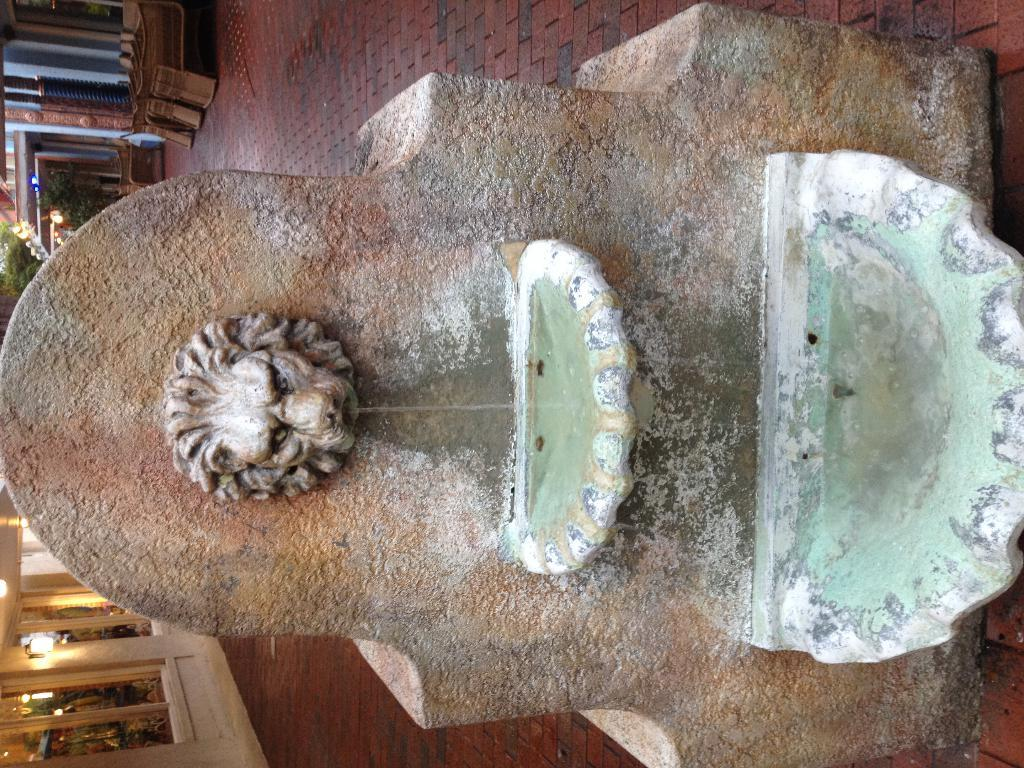What is the main feature in the center of the image? There is a fountain in the center of the image. What can be seen in the background of the image? There are pillars and trees in the background of the image. How many sisters are standing near the fountain in the image? There is no mention of sisters in the image, so we cannot determine their presence or number. 